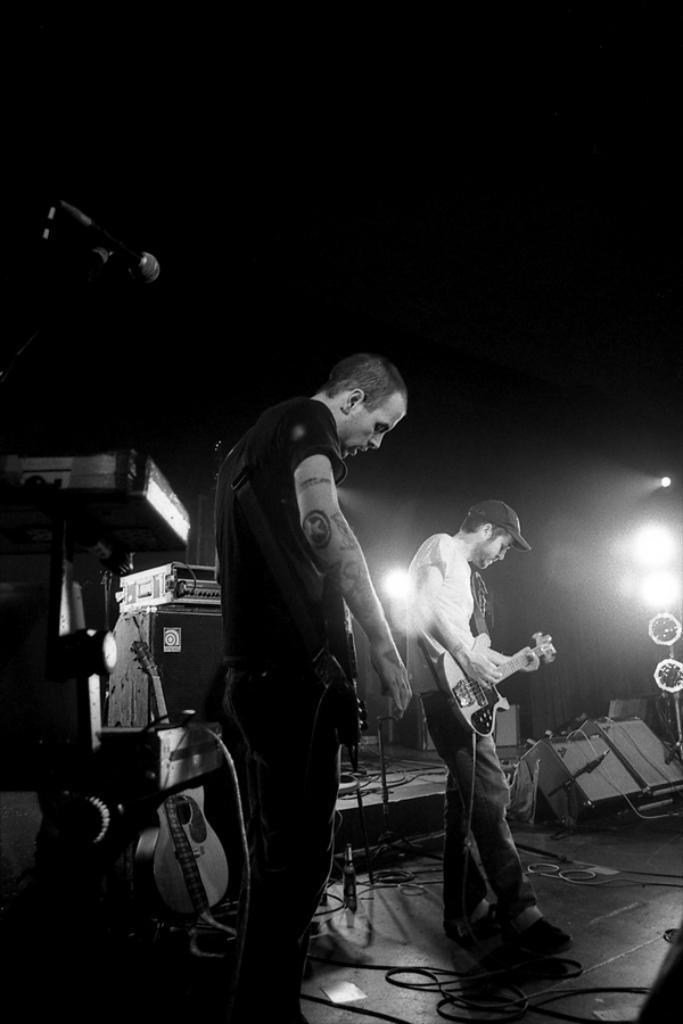Can you describe this image briefly? Here in this picture we can see two men are playing guitar. At the back of them there are some musical instruments. And the left side person is wearing a black t-shirt and the right side person is wearing a white t-shirt and a cap. And to the left top corner we can see mic. 